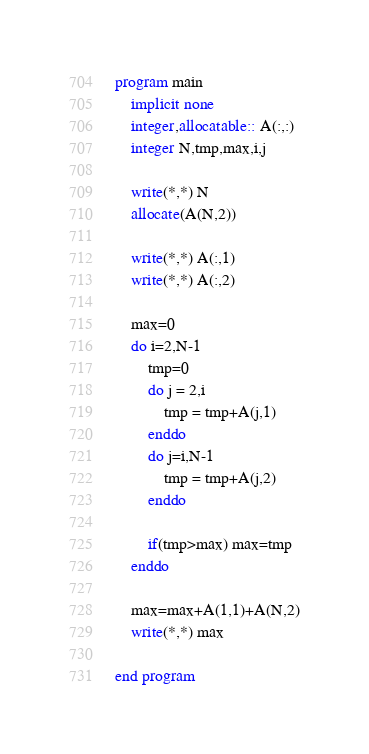<code> <loc_0><loc_0><loc_500><loc_500><_FORTRAN_>program main
    implicit none
    integer,allocatable:: A(:,:)
    integer N,tmp,max,i,j

    write(*,*) N
    allocate(A(N,2))
    
    write(*,*) A(:,1)
    write(*,*) A(:,2)

    max=0
    do i=2,N-1
        tmp=0
        do j = 2,i
            tmp = tmp+A(j,1)
        enddo
        do j=i,N-1
            tmp = tmp+A(j,2)
        enddo

        if(tmp>max) max=tmp
    enddo

    max=max+A(1,1)+A(N,2)
    write(*,*) max

end program</code> 